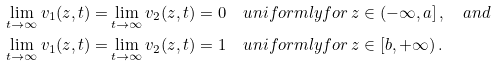<formula> <loc_0><loc_0><loc_500><loc_500>\lim _ { t \to \infty } v _ { 1 } ( z , t ) = & \lim _ { t \to \infty } v _ { 2 } ( z , t ) = 0 \quad u n i f o r m l y f o r \, z \in ( - \infty , a ] \, , \quad a n d \\ \lim _ { t \to \infty } v _ { 1 } ( z , t ) = & \lim _ { t \to \infty } v _ { 2 } ( z , t ) = 1 \quad u n i f o r m l y f o r \, z \in [ b , + \infty ) \, .</formula> 